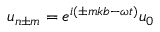<formula> <loc_0><loc_0><loc_500><loc_500>u _ { n \pm m } = e ^ { i ( \pm m k b - \omega t ) } u _ { 0 }</formula> 